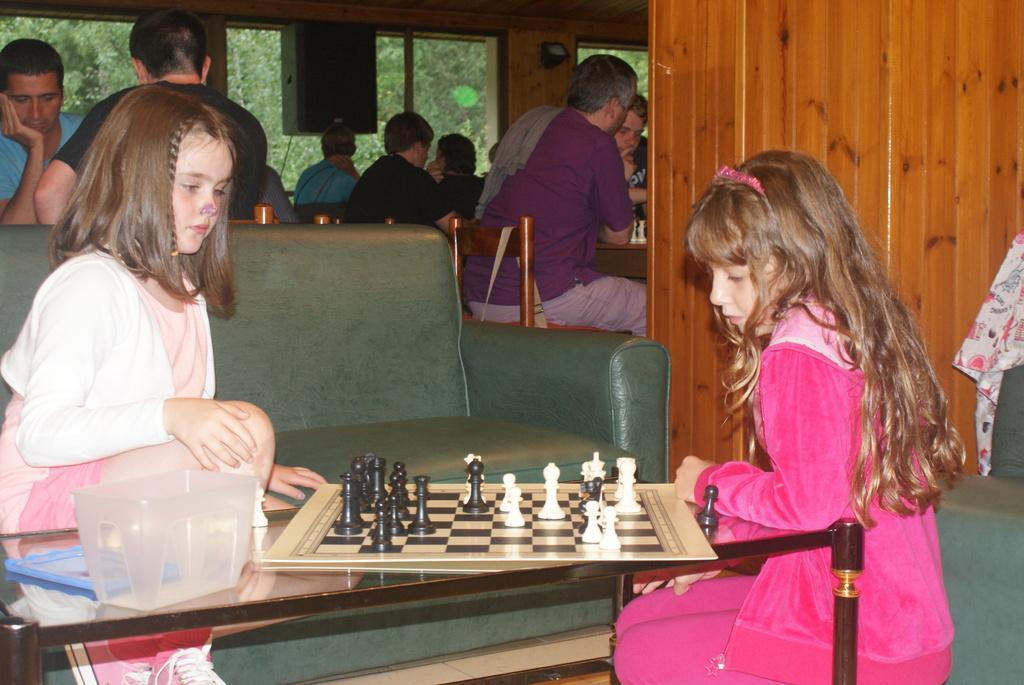Can you describe this image briefly? Front these two kids are sitting on a couch. On this table there is a container, chess board and coins. Far these persons are sitting on a chairs. From this glass window we can able to see trees. This is a speaker. 